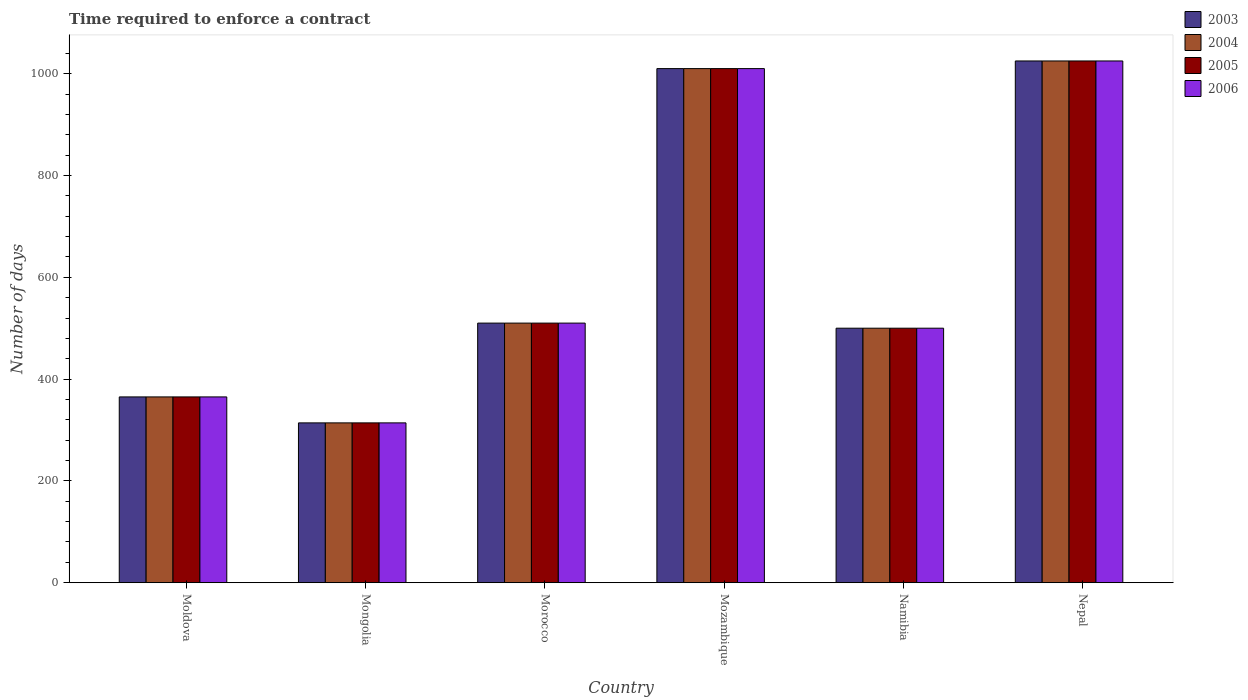How many different coloured bars are there?
Offer a terse response. 4. How many bars are there on the 3rd tick from the left?
Offer a very short reply. 4. What is the label of the 2nd group of bars from the left?
Your answer should be compact. Mongolia. What is the number of days required to enforce a contract in 2003 in Mongolia?
Keep it short and to the point. 314. Across all countries, what is the maximum number of days required to enforce a contract in 2006?
Provide a succinct answer. 1025. Across all countries, what is the minimum number of days required to enforce a contract in 2005?
Your answer should be compact. 314. In which country was the number of days required to enforce a contract in 2005 maximum?
Offer a very short reply. Nepal. In which country was the number of days required to enforce a contract in 2003 minimum?
Offer a very short reply. Mongolia. What is the total number of days required to enforce a contract in 2005 in the graph?
Your answer should be very brief. 3724. What is the difference between the number of days required to enforce a contract in 2005 in Moldova and that in Morocco?
Give a very brief answer. -145. What is the difference between the number of days required to enforce a contract in 2004 in Nepal and the number of days required to enforce a contract in 2006 in Moldova?
Ensure brevity in your answer.  660. What is the average number of days required to enforce a contract in 2005 per country?
Ensure brevity in your answer.  620.67. What is the difference between the number of days required to enforce a contract of/in 2006 and number of days required to enforce a contract of/in 2004 in Moldova?
Give a very brief answer. 0. What is the ratio of the number of days required to enforce a contract in 2004 in Mozambique to that in Namibia?
Keep it short and to the point. 2.02. Is the difference between the number of days required to enforce a contract in 2006 in Morocco and Mozambique greater than the difference between the number of days required to enforce a contract in 2004 in Morocco and Mozambique?
Give a very brief answer. No. What is the difference between the highest and the second highest number of days required to enforce a contract in 2005?
Keep it short and to the point. 15. What is the difference between the highest and the lowest number of days required to enforce a contract in 2005?
Your response must be concise. 711. In how many countries, is the number of days required to enforce a contract in 2003 greater than the average number of days required to enforce a contract in 2003 taken over all countries?
Offer a terse response. 2. Is it the case that in every country, the sum of the number of days required to enforce a contract in 2004 and number of days required to enforce a contract in 2005 is greater than the sum of number of days required to enforce a contract in 2006 and number of days required to enforce a contract in 2003?
Your response must be concise. No. Are all the bars in the graph horizontal?
Make the answer very short. No. How many countries are there in the graph?
Keep it short and to the point. 6. What is the difference between two consecutive major ticks on the Y-axis?
Make the answer very short. 200. Are the values on the major ticks of Y-axis written in scientific E-notation?
Offer a terse response. No. Does the graph contain any zero values?
Your answer should be compact. No. Does the graph contain grids?
Offer a very short reply. No. Where does the legend appear in the graph?
Your response must be concise. Top right. How are the legend labels stacked?
Your response must be concise. Vertical. What is the title of the graph?
Provide a short and direct response. Time required to enforce a contract. What is the label or title of the Y-axis?
Your answer should be compact. Number of days. What is the Number of days in 2003 in Moldova?
Your answer should be compact. 365. What is the Number of days of 2004 in Moldova?
Ensure brevity in your answer.  365. What is the Number of days of 2005 in Moldova?
Your answer should be compact. 365. What is the Number of days in 2006 in Moldova?
Make the answer very short. 365. What is the Number of days of 2003 in Mongolia?
Provide a short and direct response. 314. What is the Number of days of 2004 in Mongolia?
Your answer should be compact. 314. What is the Number of days in 2005 in Mongolia?
Offer a terse response. 314. What is the Number of days in 2006 in Mongolia?
Your answer should be very brief. 314. What is the Number of days of 2003 in Morocco?
Provide a short and direct response. 510. What is the Number of days of 2004 in Morocco?
Make the answer very short. 510. What is the Number of days of 2005 in Morocco?
Ensure brevity in your answer.  510. What is the Number of days in 2006 in Morocco?
Make the answer very short. 510. What is the Number of days of 2003 in Mozambique?
Ensure brevity in your answer.  1010. What is the Number of days in 2004 in Mozambique?
Your answer should be very brief. 1010. What is the Number of days of 2005 in Mozambique?
Your answer should be very brief. 1010. What is the Number of days in 2006 in Mozambique?
Make the answer very short. 1010. What is the Number of days in 2003 in Namibia?
Offer a very short reply. 500. What is the Number of days of 2005 in Namibia?
Ensure brevity in your answer.  500. What is the Number of days of 2006 in Namibia?
Keep it short and to the point. 500. What is the Number of days of 2003 in Nepal?
Your answer should be very brief. 1025. What is the Number of days in 2004 in Nepal?
Your answer should be very brief. 1025. What is the Number of days of 2005 in Nepal?
Make the answer very short. 1025. What is the Number of days of 2006 in Nepal?
Your answer should be compact. 1025. Across all countries, what is the maximum Number of days in 2003?
Provide a succinct answer. 1025. Across all countries, what is the maximum Number of days of 2004?
Provide a short and direct response. 1025. Across all countries, what is the maximum Number of days of 2005?
Offer a terse response. 1025. Across all countries, what is the maximum Number of days in 2006?
Give a very brief answer. 1025. Across all countries, what is the minimum Number of days in 2003?
Give a very brief answer. 314. Across all countries, what is the minimum Number of days in 2004?
Offer a terse response. 314. Across all countries, what is the minimum Number of days of 2005?
Your answer should be very brief. 314. Across all countries, what is the minimum Number of days in 2006?
Ensure brevity in your answer.  314. What is the total Number of days in 2003 in the graph?
Provide a short and direct response. 3724. What is the total Number of days in 2004 in the graph?
Offer a very short reply. 3724. What is the total Number of days in 2005 in the graph?
Provide a succinct answer. 3724. What is the total Number of days of 2006 in the graph?
Ensure brevity in your answer.  3724. What is the difference between the Number of days of 2004 in Moldova and that in Mongolia?
Provide a succinct answer. 51. What is the difference between the Number of days in 2006 in Moldova and that in Mongolia?
Offer a very short reply. 51. What is the difference between the Number of days of 2003 in Moldova and that in Morocco?
Your response must be concise. -145. What is the difference between the Number of days in 2004 in Moldova and that in Morocco?
Provide a succinct answer. -145. What is the difference between the Number of days in 2005 in Moldova and that in Morocco?
Offer a very short reply. -145. What is the difference between the Number of days of 2006 in Moldova and that in Morocco?
Ensure brevity in your answer.  -145. What is the difference between the Number of days in 2003 in Moldova and that in Mozambique?
Make the answer very short. -645. What is the difference between the Number of days of 2004 in Moldova and that in Mozambique?
Your answer should be very brief. -645. What is the difference between the Number of days in 2005 in Moldova and that in Mozambique?
Ensure brevity in your answer.  -645. What is the difference between the Number of days of 2006 in Moldova and that in Mozambique?
Your response must be concise. -645. What is the difference between the Number of days in 2003 in Moldova and that in Namibia?
Provide a succinct answer. -135. What is the difference between the Number of days of 2004 in Moldova and that in Namibia?
Provide a short and direct response. -135. What is the difference between the Number of days in 2005 in Moldova and that in Namibia?
Ensure brevity in your answer.  -135. What is the difference between the Number of days of 2006 in Moldova and that in Namibia?
Provide a succinct answer. -135. What is the difference between the Number of days of 2003 in Moldova and that in Nepal?
Make the answer very short. -660. What is the difference between the Number of days of 2004 in Moldova and that in Nepal?
Provide a short and direct response. -660. What is the difference between the Number of days in 2005 in Moldova and that in Nepal?
Make the answer very short. -660. What is the difference between the Number of days in 2006 in Moldova and that in Nepal?
Keep it short and to the point. -660. What is the difference between the Number of days in 2003 in Mongolia and that in Morocco?
Provide a short and direct response. -196. What is the difference between the Number of days of 2004 in Mongolia and that in Morocco?
Provide a short and direct response. -196. What is the difference between the Number of days of 2005 in Mongolia and that in Morocco?
Your response must be concise. -196. What is the difference between the Number of days of 2006 in Mongolia and that in Morocco?
Keep it short and to the point. -196. What is the difference between the Number of days in 2003 in Mongolia and that in Mozambique?
Your answer should be very brief. -696. What is the difference between the Number of days of 2004 in Mongolia and that in Mozambique?
Provide a succinct answer. -696. What is the difference between the Number of days in 2005 in Mongolia and that in Mozambique?
Your answer should be compact. -696. What is the difference between the Number of days in 2006 in Mongolia and that in Mozambique?
Offer a very short reply. -696. What is the difference between the Number of days in 2003 in Mongolia and that in Namibia?
Offer a very short reply. -186. What is the difference between the Number of days of 2004 in Mongolia and that in Namibia?
Your answer should be compact. -186. What is the difference between the Number of days in 2005 in Mongolia and that in Namibia?
Provide a succinct answer. -186. What is the difference between the Number of days of 2006 in Mongolia and that in Namibia?
Ensure brevity in your answer.  -186. What is the difference between the Number of days in 2003 in Mongolia and that in Nepal?
Offer a very short reply. -711. What is the difference between the Number of days of 2004 in Mongolia and that in Nepal?
Make the answer very short. -711. What is the difference between the Number of days in 2005 in Mongolia and that in Nepal?
Your answer should be very brief. -711. What is the difference between the Number of days in 2006 in Mongolia and that in Nepal?
Your response must be concise. -711. What is the difference between the Number of days of 2003 in Morocco and that in Mozambique?
Your answer should be compact. -500. What is the difference between the Number of days in 2004 in Morocco and that in Mozambique?
Give a very brief answer. -500. What is the difference between the Number of days of 2005 in Morocco and that in Mozambique?
Your answer should be very brief. -500. What is the difference between the Number of days of 2006 in Morocco and that in Mozambique?
Ensure brevity in your answer.  -500. What is the difference between the Number of days of 2003 in Morocco and that in Namibia?
Offer a terse response. 10. What is the difference between the Number of days in 2004 in Morocco and that in Namibia?
Your response must be concise. 10. What is the difference between the Number of days in 2003 in Morocco and that in Nepal?
Keep it short and to the point. -515. What is the difference between the Number of days of 2004 in Morocco and that in Nepal?
Your answer should be very brief. -515. What is the difference between the Number of days in 2005 in Morocco and that in Nepal?
Provide a short and direct response. -515. What is the difference between the Number of days in 2006 in Morocco and that in Nepal?
Your answer should be compact. -515. What is the difference between the Number of days in 2003 in Mozambique and that in Namibia?
Your answer should be very brief. 510. What is the difference between the Number of days in 2004 in Mozambique and that in Namibia?
Provide a short and direct response. 510. What is the difference between the Number of days of 2005 in Mozambique and that in Namibia?
Offer a terse response. 510. What is the difference between the Number of days of 2006 in Mozambique and that in Namibia?
Keep it short and to the point. 510. What is the difference between the Number of days of 2003 in Mozambique and that in Nepal?
Make the answer very short. -15. What is the difference between the Number of days of 2004 in Mozambique and that in Nepal?
Provide a short and direct response. -15. What is the difference between the Number of days of 2005 in Mozambique and that in Nepal?
Your answer should be compact. -15. What is the difference between the Number of days in 2006 in Mozambique and that in Nepal?
Keep it short and to the point. -15. What is the difference between the Number of days in 2003 in Namibia and that in Nepal?
Your answer should be very brief. -525. What is the difference between the Number of days of 2004 in Namibia and that in Nepal?
Provide a short and direct response. -525. What is the difference between the Number of days of 2005 in Namibia and that in Nepal?
Provide a short and direct response. -525. What is the difference between the Number of days in 2006 in Namibia and that in Nepal?
Keep it short and to the point. -525. What is the difference between the Number of days of 2003 in Moldova and the Number of days of 2004 in Mongolia?
Keep it short and to the point. 51. What is the difference between the Number of days in 2003 in Moldova and the Number of days in 2005 in Mongolia?
Offer a very short reply. 51. What is the difference between the Number of days of 2004 in Moldova and the Number of days of 2005 in Mongolia?
Provide a succinct answer. 51. What is the difference between the Number of days of 2004 in Moldova and the Number of days of 2006 in Mongolia?
Offer a very short reply. 51. What is the difference between the Number of days in 2003 in Moldova and the Number of days in 2004 in Morocco?
Your answer should be compact. -145. What is the difference between the Number of days in 2003 in Moldova and the Number of days in 2005 in Morocco?
Keep it short and to the point. -145. What is the difference between the Number of days in 2003 in Moldova and the Number of days in 2006 in Morocco?
Keep it short and to the point. -145. What is the difference between the Number of days of 2004 in Moldova and the Number of days of 2005 in Morocco?
Give a very brief answer. -145. What is the difference between the Number of days in 2004 in Moldova and the Number of days in 2006 in Morocco?
Keep it short and to the point. -145. What is the difference between the Number of days in 2005 in Moldova and the Number of days in 2006 in Morocco?
Keep it short and to the point. -145. What is the difference between the Number of days in 2003 in Moldova and the Number of days in 2004 in Mozambique?
Your answer should be compact. -645. What is the difference between the Number of days of 2003 in Moldova and the Number of days of 2005 in Mozambique?
Give a very brief answer. -645. What is the difference between the Number of days of 2003 in Moldova and the Number of days of 2006 in Mozambique?
Keep it short and to the point. -645. What is the difference between the Number of days in 2004 in Moldova and the Number of days in 2005 in Mozambique?
Provide a succinct answer. -645. What is the difference between the Number of days in 2004 in Moldova and the Number of days in 2006 in Mozambique?
Offer a very short reply. -645. What is the difference between the Number of days of 2005 in Moldova and the Number of days of 2006 in Mozambique?
Provide a short and direct response. -645. What is the difference between the Number of days in 2003 in Moldova and the Number of days in 2004 in Namibia?
Your response must be concise. -135. What is the difference between the Number of days in 2003 in Moldova and the Number of days in 2005 in Namibia?
Your response must be concise. -135. What is the difference between the Number of days of 2003 in Moldova and the Number of days of 2006 in Namibia?
Your answer should be very brief. -135. What is the difference between the Number of days of 2004 in Moldova and the Number of days of 2005 in Namibia?
Offer a terse response. -135. What is the difference between the Number of days of 2004 in Moldova and the Number of days of 2006 in Namibia?
Provide a short and direct response. -135. What is the difference between the Number of days in 2005 in Moldova and the Number of days in 2006 in Namibia?
Keep it short and to the point. -135. What is the difference between the Number of days in 2003 in Moldova and the Number of days in 2004 in Nepal?
Offer a very short reply. -660. What is the difference between the Number of days of 2003 in Moldova and the Number of days of 2005 in Nepal?
Offer a terse response. -660. What is the difference between the Number of days of 2003 in Moldova and the Number of days of 2006 in Nepal?
Your response must be concise. -660. What is the difference between the Number of days of 2004 in Moldova and the Number of days of 2005 in Nepal?
Provide a succinct answer. -660. What is the difference between the Number of days of 2004 in Moldova and the Number of days of 2006 in Nepal?
Make the answer very short. -660. What is the difference between the Number of days of 2005 in Moldova and the Number of days of 2006 in Nepal?
Offer a terse response. -660. What is the difference between the Number of days in 2003 in Mongolia and the Number of days in 2004 in Morocco?
Give a very brief answer. -196. What is the difference between the Number of days in 2003 in Mongolia and the Number of days in 2005 in Morocco?
Your response must be concise. -196. What is the difference between the Number of days in 2003 in Mongolia and the Number of days in 2006 in Morocco?
Offer a terse response. -196. What is the difference between the Number of days of 2004 in Mongolia and the Number of days of 2005 in Morocco?
Ensure brevity in your answer.  -196. What is the difference between the Number of days in 2004 in Mongolia and the Number of days in 2006 in Morocco?
Offer a terse response. -196. What is the difference between the Number of days of 2005 in Mongolia and the Number of days of 2006 in Morocco?
Offer a very short reply. -196. What is the difference between the Number of days in 2003 in Mongolia and the Number of days in 2004 in Mozambique?
Give a very brief answer. -696. What is the difference between the Number of days of 2003 in Mongolia and the Number of days of 2005 in Mozambique?
Keep it short and to the point. -696. What is the difference between the Number of days in 2003 in Mongolia and the Number of days in 2006 in Mozambique?
Ensure brevity in your answer.  -696. What is the difference between the Number of days in 2004 in Mongolia and the Number of days in 2005 in Mozambique?
Your answer should be very brief. -696. What is the difference between the Number of days in 2004 in Mongolia and the Number of days in 2006 in Mozambique?
Your answer should be very brief. -696. What is the difference between the Number of days in 2005 in Mongolia and the Number of days in 2006 in Mozambique?
Provide a short and direct response. -696. What is the difference between the Number of days of 2003 in Mongolia and the Number of days of 2004 in Namibia?
Offer a very short reply. -186. What is the difference between the Number of days in 2003 in Mongolia and the Number of days in 2005 in Namibia?
Ensure brevity in your answer.  -186. What is the difference between the Number of days in 2003 in Mongolia and the Number of days in 2006 in Namibia?
Ensure brevity in your answer.  -186. What is the difference between the Number of days in 2004 in Mongolia and the Number of days in 2005 in Namibia?
Your response must be concise. -186. What is the difference between the Number of days in 2004 in Mongolia and the Number of days in 2006 in Namibia?
Ensure brevity in your answer.  -186. What is the difference between the Number of days in 2005 in Mongolia and the Number of days in 2006 in Namibia?
Your answer should be very brief. -186. What is the difference between the Number of days of 2003 in Mongolia and the Number of days of 2004 in Nepal?
Offer a very short reply. -711. What is the difference between the Number of days in 2003 in Mongolia and the Number of days in 2005 in Nepal?
Your answer should be compact. -711. What is the difference between the Number of days in 2003 in Mongolia and the Number of days in 2006 in Nepal?
Ensure brevity in your answer.  -711. What is the difference between the Number of days in 2004 in Mongolia and the Number of days in 2005 in Nepal?
Provide a short and direct response. -711. What is the difference between the Number of days in 2004 in Mongolia and the Number of days in 2006 in Nepal?
Provide a short and direct response. -711. What is the difference between the Number of days in 2005 in Mongolia and the Number of days in 2006 in Nepal?
Ensure brevity in your answer.  -711. What is the difference between the Number of days of 2003 in Morocco and the Number of days of 2004 in Mozambique?
Ensure brevity in your answer.  -500. What is the difference between the Number of days of 2003 in Morocco and the Number of days of 2005 in Mozambique?
Keep it short and to the point. -500. What is the difference between the Number of days in 2003 in Morocco and the Number of days in 2006 in Mozambique?
Give a very brief answer. -500. What is the difference between the Number of days of 2004 in Morocco and the Number of days of 2005 in Mozambique?
Provide a succinct answer. -500. What is the difference between the Number of days of 2004 in Morocco and the Number of days of 2006 in Mozambique?
Your response must be concise. -500. What is the difference between the Number of days in 2005 in Morocco and the Number of days in 2006 in Mozambique?
Offer a terse response. -500. What is the difference between the Number of days in 2003 in Morocco and the Number of days in 2004 in Namibia?
Ensure brevity in your answer.  10. What is the difference between the Number of days of 2003 in Morocco and the Number of days of 2005 in Namibia?
Your answer should be very brief. 10. What is the difference between the Number of days of 2005 in Morocco and the Number of days of 2006 in Namibia?
Your response must be concise. 10. What is the difference between the Number of days in 2003 in Morocco and the Number of days in 2004 in Nepal?
Make the answer very short. -515. What is the difference between the Number of days of 2003 in Morocco and the Number of days of 2005 in Nepal?
Your answer should be very brief. -515. What is the difference between the Number of days in 2003 in Morocco and the Number of days in 2006 in Nepal?
Provide a succinct answer. -515. What is the difference between the Number of days of 2004 in Morocco and the Number of days of 2005 in Nepal?
Ensure brevity in your answer.  -515. What is the difference between the Number of days of 2004 in Morocco and the Number of days of 2006 in Nepal?
Your response must be concise. -515. What is the difference between the Number of days of 2005 in Morocco and the Number of days of 2006 in Nepal?
Offer a terse response. -515. What is the difference between the Number of days in 2003 in Mozambique and the Number of days in 2004 in Namibia?
Make the answer very short. 510. What is the difference between the Number of days in 2003 in Mozambique and the Number of days in 2005 in Namibia?
Make the answer very short. 510. What is the difference between the Number of days in 2003 in Mozambique and the Number of days in 2006 in Namibia?
Provide a short and direct response. 510. What is the difference between the Number of days of 2004 in Mozambique and the Number of days of 2005 in Namibia?
Keep it short and to the point. 510. What is the difference between the Number of days of 2004 in Mozambique and the Number of days of 2006 in Namibia?
Keep it short and to the point. 510. What is the difference between the Number of days in 2005 in Mozambique and the Number of days in 2006 in Namibia?
Keep it short and to the point. 510. What is the difference between the Number of days of 2003 in Mozambique and the Number of days of 2004 in Nepal?
Ensure brevity in your answer.  -15. What is the difference between the Number of days in 2003 in Mozambique and the Number of days in 2005 in Nepal?
Your answer should be compact. -15. What is the difference between the Number of days of 2003 in Mozambique and the Number of days of 2006 in Nepal?
Offer a terse response. -15. What is the difference between the Number of days of 2004 in Mozambique and the Number of days of 2005 in Nepal?
Offer a very short reply. -15. What is the difference between the Number of days of 2004 in Mozambique and the Number of days of 2006 in Nepal?
Your answer should be compact. -15. What is the difference between the Number of days in 2003 in Namibia and the Number of days in 2004 in Nepal?
Make the answer very short. -525. What is the difference between the Number of days of 2003 in Namibia and the Number of days of 2005 in Nepal?
Offer a terse response. -525. What is the difference between the Number of days in 2003 in Namibia and the Number of days in 2006 in Nepal?
Ensure brevity in your answer.  -525. What is the difference between the Number of days of 2004 in Namibia and the Number of days of 2005 in Nepal?
Your answer should be very brief. -525. What is the difference between the Number of days in 2004 in Namibia and the Number of days in 2006 in Nepal?
Provide a succinct answer. -525. What is the difference between the Number of days in 2005 in Namibia and the Number of days in 2006 in Nepal?
Your answer should be very brief. -525. What is the average Number of days in 2003 per country?
Make the answer very short. 620.67. What is the average Number of days in 2004 per country?
Your response must be concise. 620.67. What is the average Number of days of 2005 per country?
Your answer should be compact. 620.67. What is the average Number of days of 2006 per country?
Your answer should be compact. 620.67. What is the difference between the Number of days of 2003 and Number of days of 2004 in Moldova?
Keep it short and to the point. 0. What is the difference between the Number of days in 2004 and Number of days in 2006 in Moldova?
Make the answer very short. 0. What is the difference between the Number of days in 2005 and Number of days in 2006 in Moldova?
Ensure brevity in your answer.  0. What is the difference between the Number of days of 2003 and Number of days of 2004 in Mongolia?
Keep it short and to the point. 0. What is the difference between the Number of days in 2003 and Number of days in 2005 in Mongolia?
Offer a terse response. 0. What is the difference between the Number of days of 2003 and Number of days of 2006 in Mongolia?
Your answer should be compact. 0. What is the difference between the Number of days in 2004 and Number of days in 2005 in Mongolia?
Your answer should be very brief. 0. What is the difference between the Number of days in 2004 and Number of days in 2006 in Mongolia?
Give a very brief answer. 0. What is the difference between the Number of days in 2004 and Number of days in 2006 in Morocco?
Offer a very short reply. 0. What is the difference between the Number of days of 2005 and Number of days of 2006 in Morocco?
Your answer should be very brief. 0. What is the difference between the Number of days in 2003 and Number of days in 2004 in Mozambique?
Make the answer very short. 0. What is the difference between the Number of days in 2003 and Number of days in 2005 in Mozambique?
Keep it short and to the point. 0. What is the difference between the Number of days in 2003 and Number of days in 2006 in Mozambique?
Make the answer very short. 0. What is the difference between the Number of days in 2005 and Number of days in 2006 in Mozambique?
Give a very brief answer. 0. What is the difference between the Number of days in 2003 and Number of days in 2006 in Namibia?
Your answer should be very brief. 0. What is the difference between the Number of days of 2004 and Number of days of 2005 in Namibia?
Provide a short and direct response. 0. What is the difference between the Number of days of 2004 and Number of days of 2006 in Namibia?
Make the answer very short. 0. What is the difference between the Number of days in 2003 and Number of days in 2005 in Nepal?
Your answer should be compact. 0. What is the difference between the Number of days of 2003 and Number of days of 2006 in Nepal?
Ensure brevity in your answer.  0. What is the difference between the Number of days of 2004 and Number of days of 2005 in Nepal?
Ensure brevity in your answer.  0. What is the difference between the Number of days in 2004 and Number of days in 2006 in Nepal?
Your answer should be very brief. 0. What is the difference between the Number of days of 2005 and Number of days of 2006 in Nepal?
Make the answer very short. 0. What is the ratio of the Number of days in 2003 in Moldova to that in Mongolia?
Make the answer very short. 1.16. What is the ratio of the Number of days in 2004 in Moldova to that in Mongolia?
Give a very brief answer. 1.16. What is the ratio of the Number of days in 2005 in Moldova to that in Mongolia?
Your response must be concise. 1.16. What is the ratio of the Number of days in 2006 in Moldova to that in Mongolia?
Provide a succinct answer. 1.16. What is the ratio of the Number of days of 2003 in Moldova to that in Morocco?
Offer a very short reply. 0.72. What is the ratio of the Number of days of 2004 in Moldova to that in Morocco?
Offer a very short reply. 0.72. What is the ratio of the Number of days in 2005 in Moldova to that in Morocco?
Your answer should be very brief. 0.72. What is the ratio of the Number of days of 2006 in Moldova to that in Morocco?
Your response must be concise. 0.72. What is the ratio of the Number of days in 2003 in Moldova to that in Mozambique?
Keep it short and to the point. 0.36. What is the ratio of the Number of days in 2004 in Moldova to that in Mozambique?
Your answer should be compact. 0.36. What is the ratio of the Number of days in 2005 in Moldova to that in Mozambique?
Your answer should be compact. 0.36. What is the ratio of the Number of days in 2006 in Moldova to that in Mozambique?
Your response must be concise. 0.36. What is the ratio of the Number of days of 2003 in Moldova to that in Namibia?
Your answer should be compact. 0.73. What is the ratio of the Number of days of 2004 in Moldova to that in Namibia?
Your response must be concise. 0.73. What is the ratio of the Number of days in 2005 in Moldova to that in Namibia?
Give a very brief answer. 0.73. What is the ratio of the Number of days in 2006 in Moldova to that in Namibia?
Your answer should be compact. 0.73. What is the ratio of the Number of days of 2003 in Moldova to that in Nepal?
Give a very brief answer. 0.36. What is the ratio of the Number of days in 2004 in Moldova to that in Nepal?
Your answer should be compact. 0.36. What is the ratio of the Number of days in 2005 in Moldova to that in Nepal?
Make the answer very short. 0.36. What is the ratio of the Number of days of 2006 in Moldova to that in Nepal?
Give a very brief answer. 0.36. What is the ratio of the Number of days of 2003 in Mongolia to that in Morocco?
Your answer should be compact. 0.62. What is the ratio of the Number of days of 2004 in Mongolia to that in Morocco?
Ensure brevity in your answer.  0.62. What is the ratio of the Number of days in 2005 in Mongolia to that in Morocco?
Your response must be concise. 0.62. What is the ratio of the Number of days in 2006 in Mongolia to that in Morocco?
Keep it short and to the point. 0.62. What is the ratio of the Number of days of 2003 in Mongolia to that in Mozambique?
Provide a short and direct response. 0.31. What is the ratio of the Number of days in 2004 in Mongolia to that in Mozambique?
Your response must be concise. 0.31. What is the ratio of the Number of days of 2005 in Mongolia to that in Mozambique?
Give a very brief answer. 0.31. What is the ratio of the Number of days in 2006 in Mongolia to that in Mozambique?
Offer a terse response. 0.31. What is the ratio of the Number of days of 2003 in Mongolia to that in Namibia?
Your response must be concise. 0.63. What is the ratio of the Number of days of 2004 in Mongolia to that in Namibia?
Keep it short and to the point. 0.63. What is the ratio of the Number of days in 2005 in Mongolia to that in Namibia?
Provide a succinct answer. 0.63. What is the ratio of the Number of days in 2006 in Mongolia to that in Namibia?
Your answer should be very brief. 0.63. What is the ratio of the Number of days in 2003 in Mongolia to that in Nepal?
Ensure brevity in your answer.  0.31. What is the ratio of the Number of days in 2004 in Mongolia to that in Nepal?
Make the answer very short. 0.31. What is the ratio of the Number of days in 2005 in Mongolia to that in Nepal?
Give a very brief answer. 0.31. What is the ratio of the Number of days of 2006 in Mongolia to that in Nepal?
Your answer should be compact. 0.31. What is the ratio of the Number of days of 2003 in Morocco to that in Mozambique?
Give a very brief answer. 0.51. What is the ratio of the Number of days of 2004 in Morocco to that in Mozambique?
Ensure brevity in your answer.  0.51. What is the ratio of the Number of days of 2005 in Morocco to that in Mozambique?
Give a very brief answer. 0.51. What is the ratio of the Number of days in 2006 in Morocco to that in Mozambique?
Provide a short and direct response. 0.51. What is the ratio of the Number of days of 2003 in Morocco to that in Namibia?
Provide a short and direct response. 1.02. What is the ratio of the Number of days in 2005 in Morocco to that in Namibia?
Provide a succinct answer. 1.02. What is the ratio of the Number of days of 2006 in Morocco to that in Namibia?
Offer a very short reply. 1.02. What is the ratio of the Number of days in 2003 in Morocco to that in Nepal?
Your response must be concise. 0.5. What is the ratio of the Number of days in 2004 in Morocco to that in Nepal?
Offer a very short reply. 0.5. What is the ratio of the Number of days of 2005 in Morocco to that in Nepal?
Your answer should be compact. 0.5. What is the ratio of the Number of days of 2006 in Morocco to that in Nepal?
Give a very brief answer. 0.5. What is the ratio of the Number of days in 2003 in Mozambique to that in Namibia?
Your answer should be very brief. 2.02. What is the ratio of the Number of days of 2004 in Mozambique to that in Namibia?
Your response must be concise. 2.02. What is the ratio of the Number of days in 2005 in Mozambique to that in Namibia?
Offer a terse response. 2.02. What is the ratio of the Number of days of 2006 in Mozambique to that in Namibia?
Your answer should be compact. 2.02. What is the ratio of the Number of days in 2003 in Mozambique to that in Nepal?
Ensure brevity in your answer.  0.99. What is the ratio of the Number of days in 2004 in Mozambique to that in Nepal?
Your response must be concise. 0.99. What is the ratio of the Number of days of 2005 in Mozambique to that in Nepal?
Your response must be concise. 0.99. What is the ratio of the Number of days in 2006 in Mozambique to that in Nepal?
Your answer should be compact. 0.99. What is the ratio of the Number of days in 2003 in Namibia to that in Nepal?
Offer a terse response. 0.49. What is the ratio of the Number of days of 2004 in Namibia to that in Nepal?
Ensure brevity in your answer.  0.49. What is the ratio of the Number of days of 2005 in Namibia to that in Nepal?
Ensure brevity in your answer.  0.49. What is the ratio of the Number of days in 2006 in Namibia to that in Nepal?
Offer a terse response. 0.49. What is the difference between the highest and the second highest Number of days in 2004?
Ensure brevity in your answer.  15. What is the difference between the highest and the second highest Number of days of 2005?
Offer a terse response. 15. What is the difference between the highest and the lowest Number of days of 2003?
Offer a terse response. 711. What is the difference between the highest and the lowest Number of days of 2004?
Your answer should be compact. 711. What is the difference between the highest and the lowest Number of days of 2005?
Your answer should be very brief. 711. What is the difference between the highest and the lowest Number of days in 2006?
Provide a succinct answer. 711. 